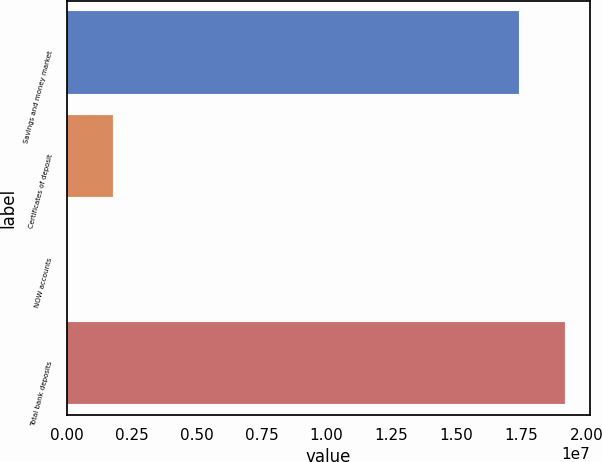<chart> <loc_0><loc_0><loc_500><loc_500><bar_chart><fcel>Savings and money market<fcel>Certificates of deposit<fcel>NOW accounts<fcel>Total bank deposits<nl><fcel>1.73911e+07<fcel>1.77791e+06<fcel>5197<fcel>1.91638e+07<nl></chart> 